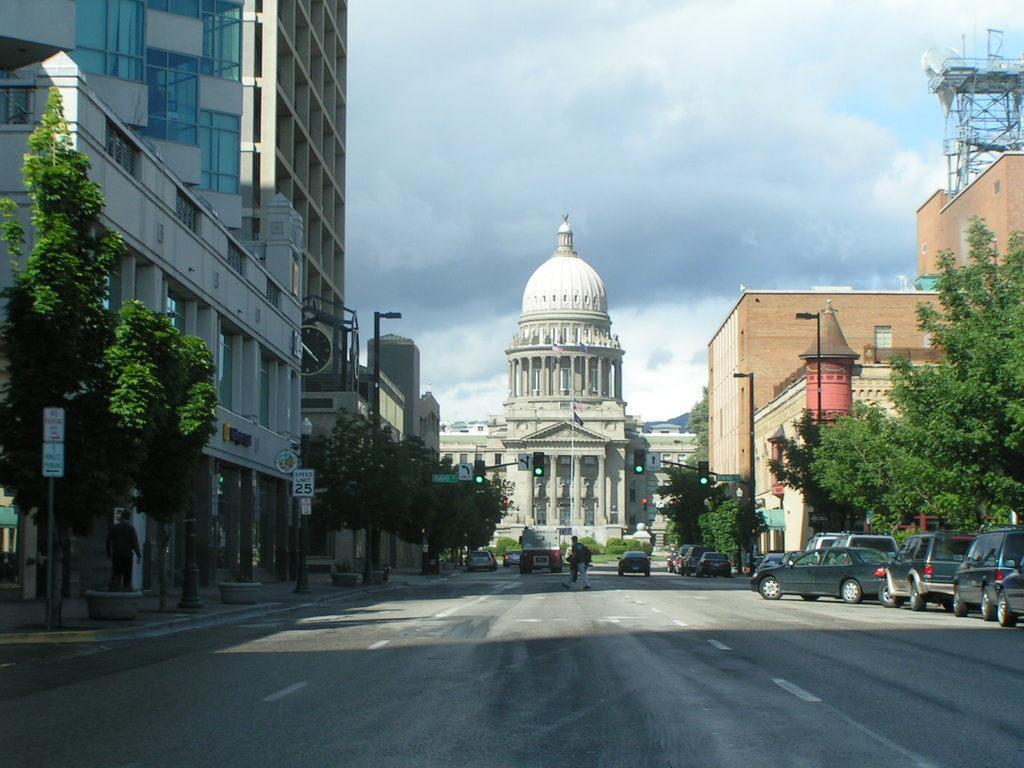Can you describe this image briefly? At the bottom of the image, on the road there are few vehicles. On the left side of the image, on the footpath there are potted plants, poles with sign boards and trees. Behind those things there are buildings. On the right side of the image there are trees and poles with traffic signals. Behind those things there are buildings. In the background there is a building with pillars, walls, roofs and windows. 